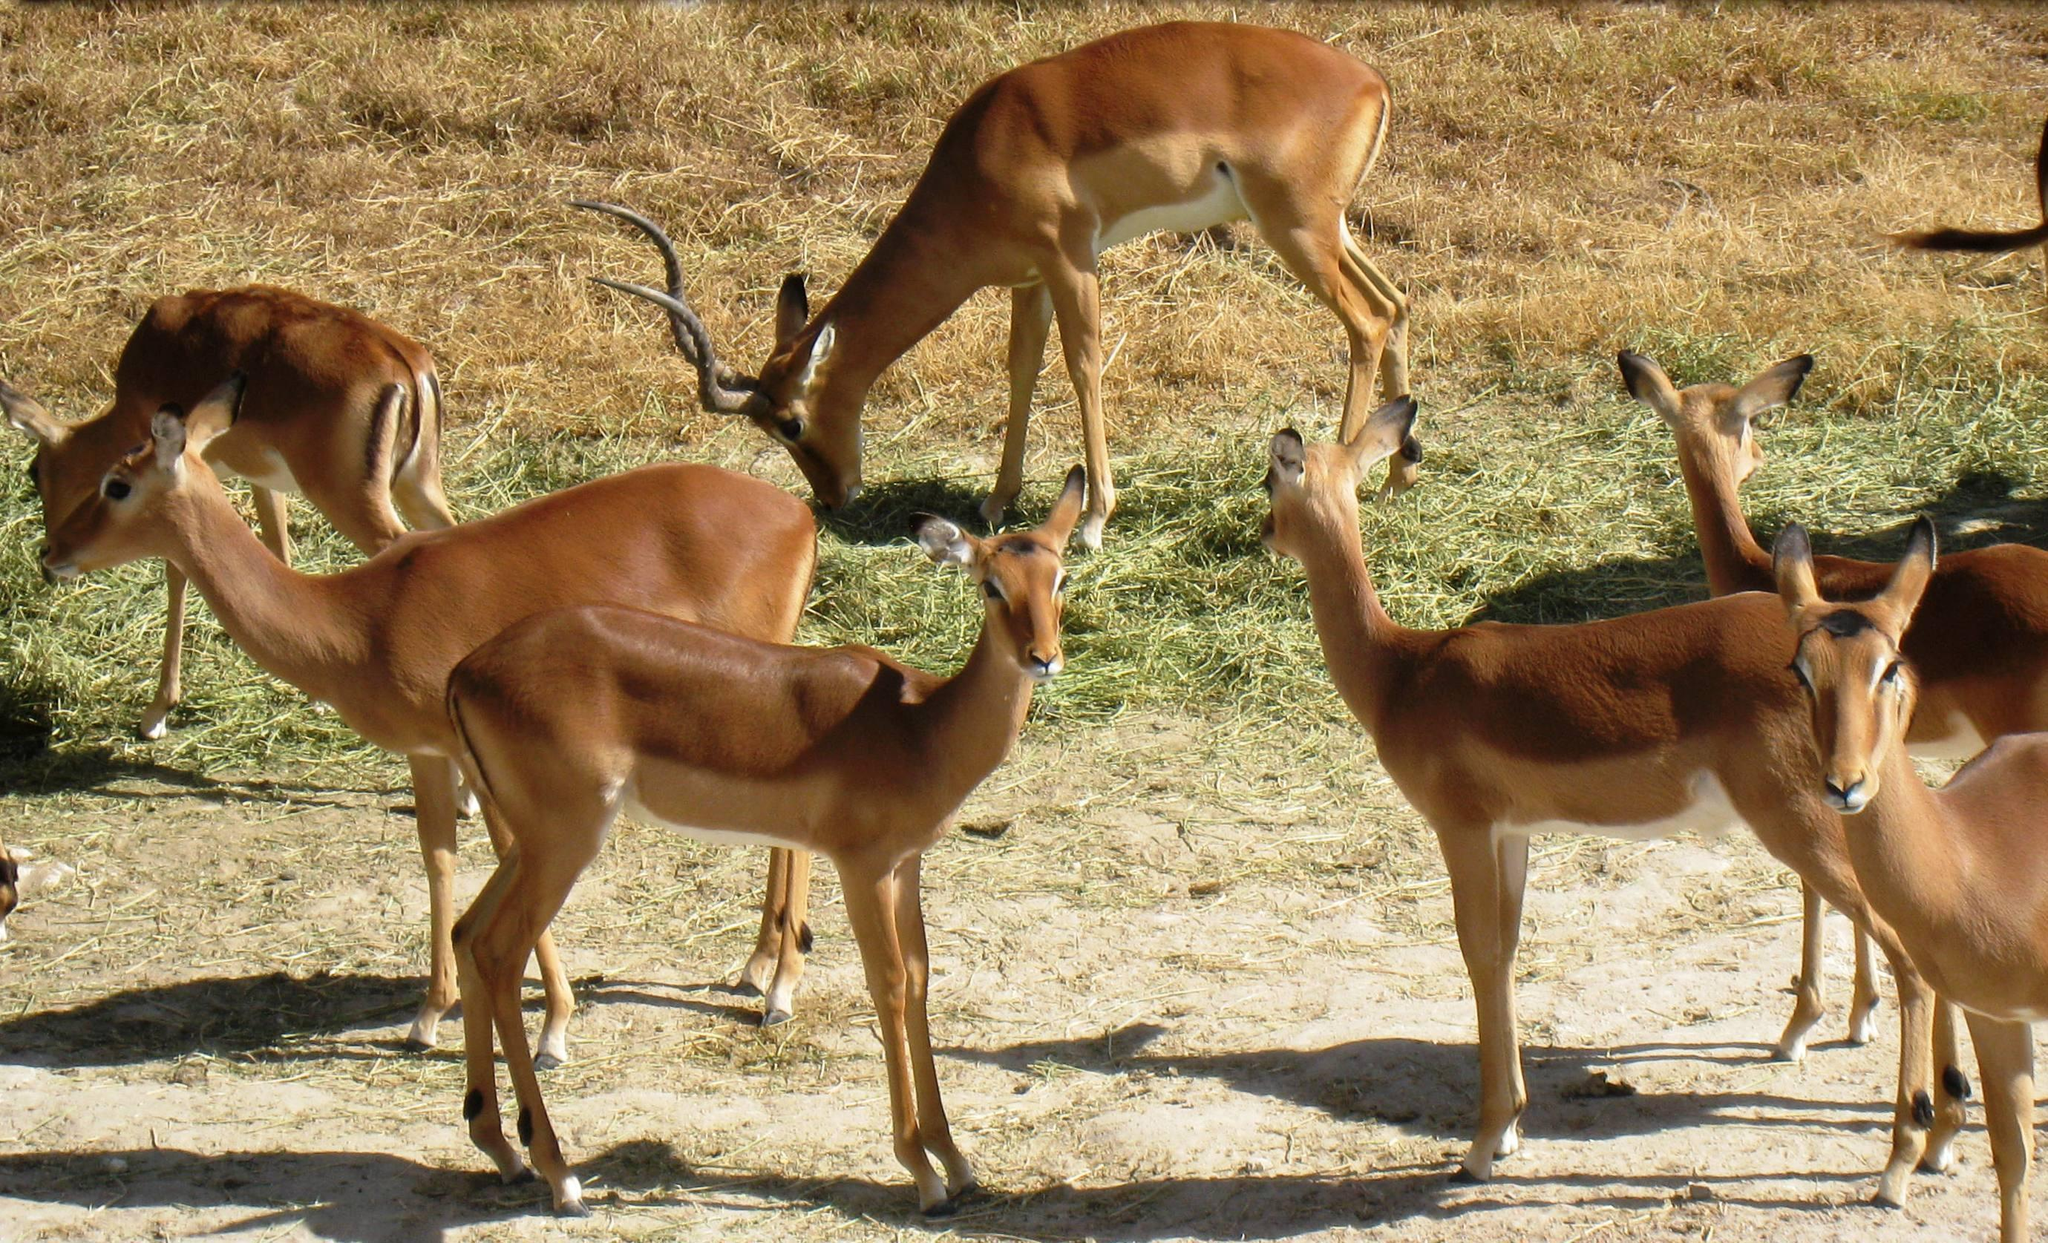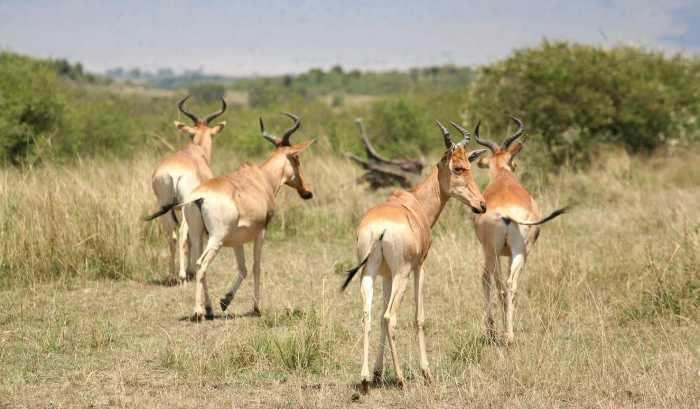The first image is the image on the left, the second image is the image on the right. Given the left and right images, does the statement "There are at least four animals in the image on the right." hold true? Answer yes or no. Yes. 